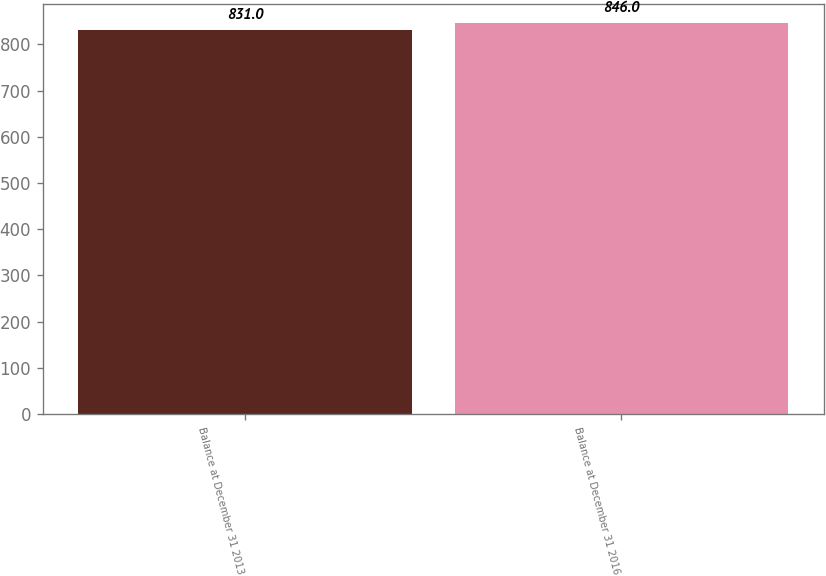Convert chart. <chart><loc_0><loc_0><loc_500><loc_500><bar_chart><fcel>Balance at December 31 2013<fcel>Balance at December 31 2016<nl><fcel>831<fcel>846<nl></chart> 